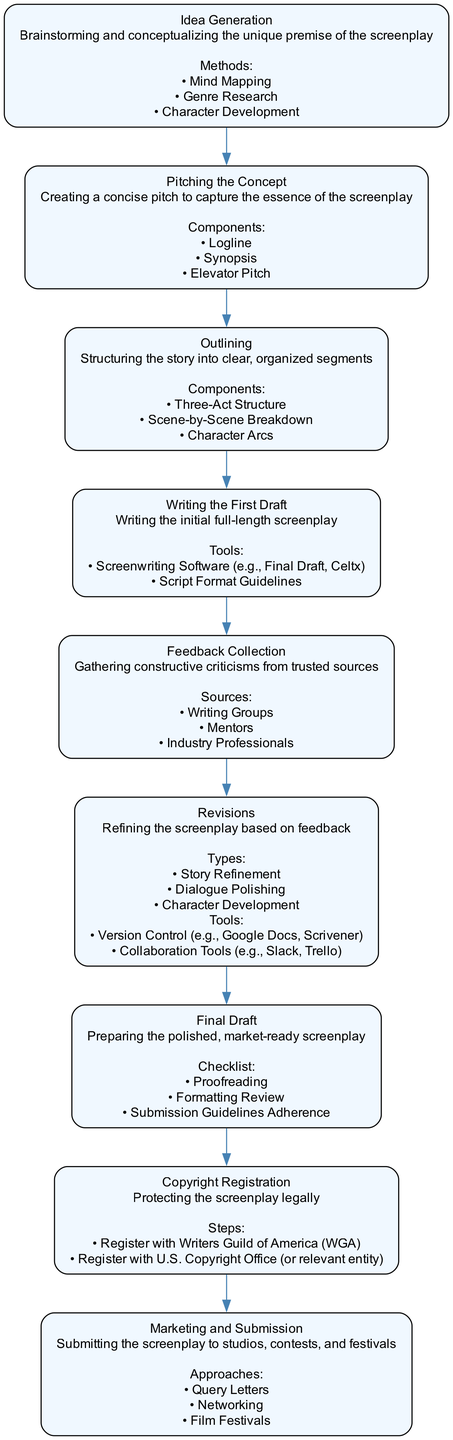What is the first step in the screenplay development process? The diagram identifies "Idea Generation" as the first step, indicating that this process begins with brainstorming and conceptualizing unique premises.
Answer: Idea Generation How many nodes are in the diagram? By counting each of the distinct steps represented in the diagram, which total eight, we establish the total number of nodes.
Answer: Eight What follows after "Writing the First Draft"? The flowchart shows that "Feedback Collection" directly follows "Writing the First Draft," indicating that the next stage involves gathering constructive criticism.
Answer: Feedback Collection Which step focuses on protecting the screenplay legally? In the diagram, "Copyright Registration" is the step specifically concerned with legal protection of the screenplay.
Answer: Copyright Registration What two methods of feedback collection are mentioned in the diagram? The diagram lists "Writing Groups" and "Mentors" as two sources for collecting feedback, highlighting trusted avenues for constructive criticism.
Answer: Writing Groups, Mentors Which step includes "Proofreading" in its checklist? The step labeled "Final Draft" includes "Proofreading" as part of its preparation process, indicating important tasks before submission.
Answer: Final Draft Why is "Outlining" crucial in screenplay development? "Outlining" is essential as it structures the story into organized segments, ensuring coherence and clarity before starting the actual writing.
Answer: Structuring the story What step directly precedes "Marketing and Submission"? According to the flowchart, "Copyright Registration" comes just before "Marketing and Submission," suggesting legal protection must be secured first.
Answer: Copyright Registration What is one approach mentioned for "Marketing and Submission"? The diagram specifies "Query Letters" as one of the approaches for submitting the screenplay, indicating a method of seeking opportunities in the industry.
Answer: Query Letters 